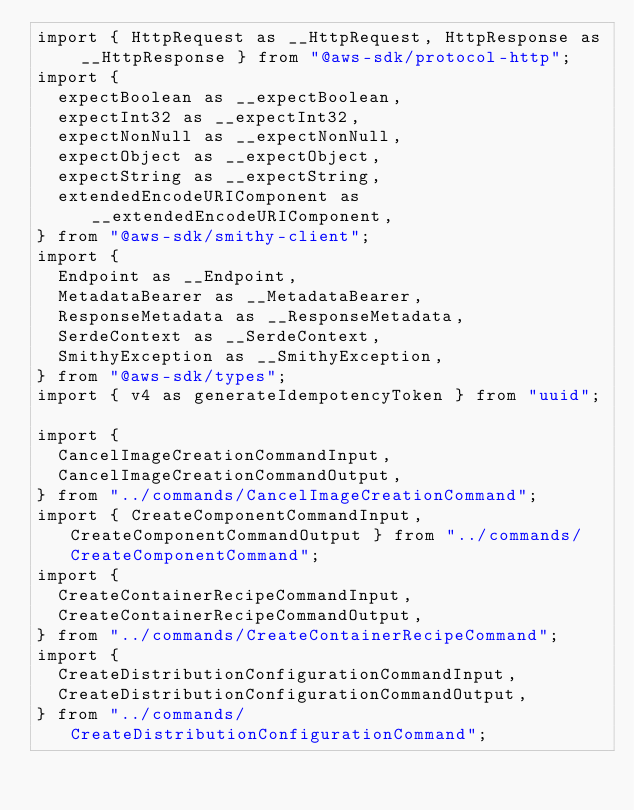Convert code to text. <code><loc_0><loc_0><loc_500><loc_500><_TypeScript_>import { HttpRequest as __HttpRequest, HttpResponse as __HttpResponse } from "@aws-sdk/protocol-http";
import {
  expectBoolean as __expectBoolean,
  expectInt32 as __expectInt32,
  expectNonNull as __expectNonNull,
  expectObject as __expectObject,
  expectString as __expectString,
  extendedEncodeURIComponent as __extendedEncodeURIComponent,
} from "@aws-sdk/smithy-client";
import {
  Endpoint as __Endpoint,
  MetadataBearer as __MetadataBearer,
  ResponseMetadata as __ResponseMetadata,
  SerdeContext as __SerdeContext,
  SmithyException as __SmithyException,
} from "@aws-sdk/types";
import { v4 as generateIdempotencyToken } from "uuid";

import {
  CancelImageCreationCommandInput,
  CancelImageCreationCommandOutput,
} from "../commands/CancelImageCreationCommand";
import { CreateComponentCommandInput, CreateComponentCommandOutput } from "../commands/CreateComponentCommand";
import {
  CreateContainerRecipeCommandInput,
  CreateContainerRecipeCommandOutput,
} from "../commands/CreateContainerRecipeCommand";
import {
  CreateDistributionConfigurationCommandInput,
  CreateDistributionConfigurationCommandOutput,
} from "../commands/CreateDistributionConfigurationCommand";</code> 